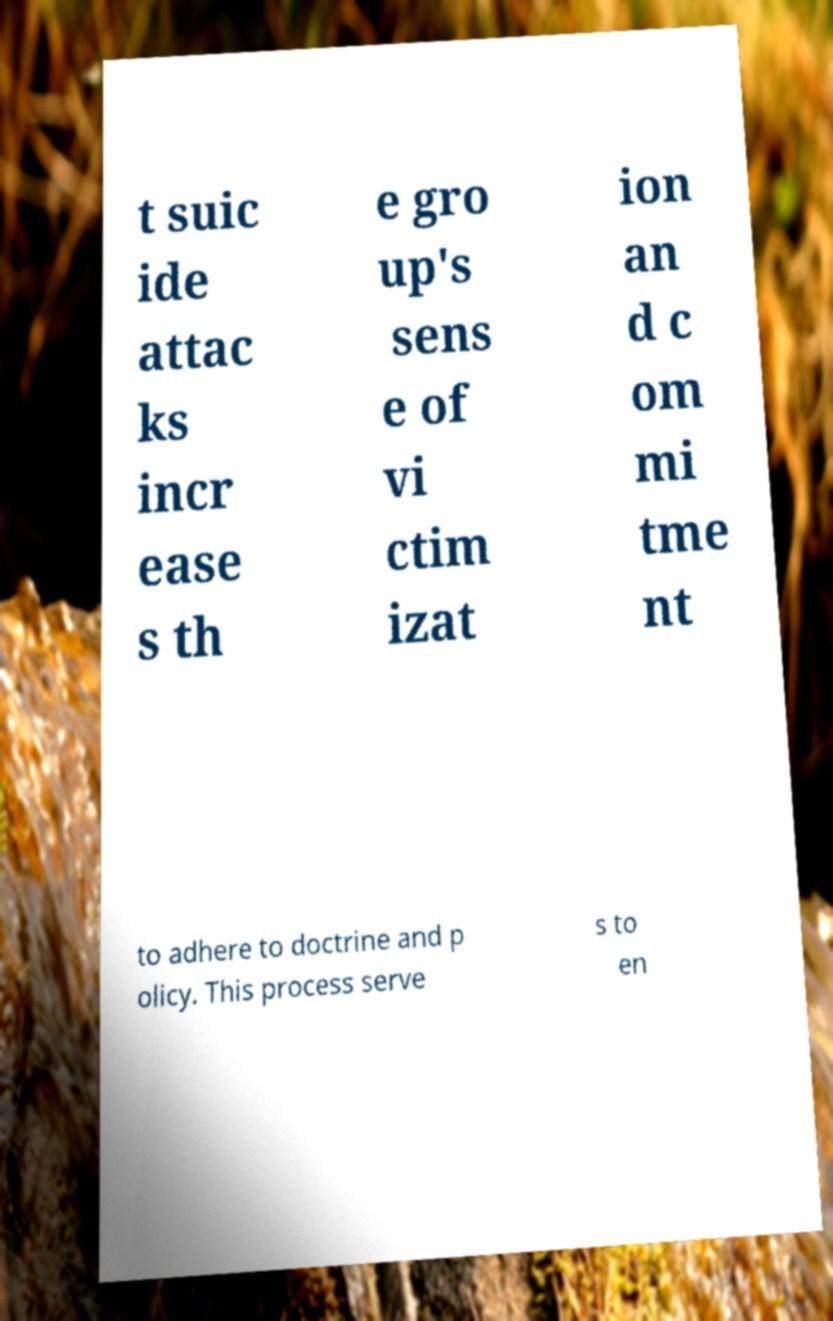What messages or text are displayed in this image? I need them in a readable, typed format. t suic ide attac ks incr ease s th e gro up's sens e of vi ctim izat ion an d c om mi tme nt to adhere to doctrine and p olicy. This process serve s to en 